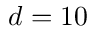Convert formula to latex. <formula><loc_0><loc_0><loc_500><loc_500>d = 1 0</formula> 